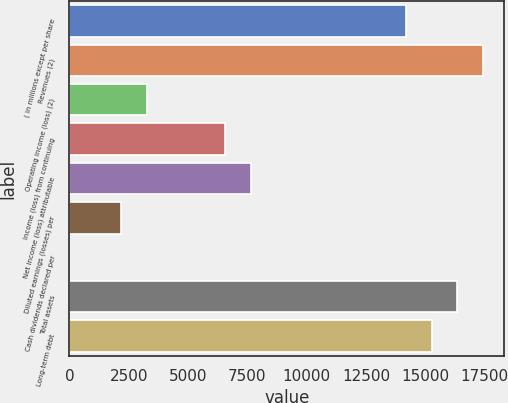Convert chart. <chart><loc_0><loc_0><loc_500><loc_500><bar_chart><fcel>( in millions except per share<fcel>Revenues (2)<fcel>Operating income (loss) (2)<fcel>Income (loss) from continuing<fcel>Net income (loss) attributable<fcel>Diluted earnings (losses) per<fcel>Cash dividends declared per<fcel>Total assets<fcel>Long-term debt<nl><fcel>14180.4<fcel>17452.7<fcel>3272.46<fcel>6544.83<fcel>7635.62<fcel>2181.67<fcel>0.09<fcel>16361.9<fcel>15271.1<nl></chart> 